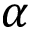Convert formula to latex. <formula><loc_0><loc_0><loc_500><loc_500>\alpha</formula> 